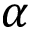Convert formula to latex. <formula><loc_0><loc_0><loc_500><loc_500>\alpha</formula> 